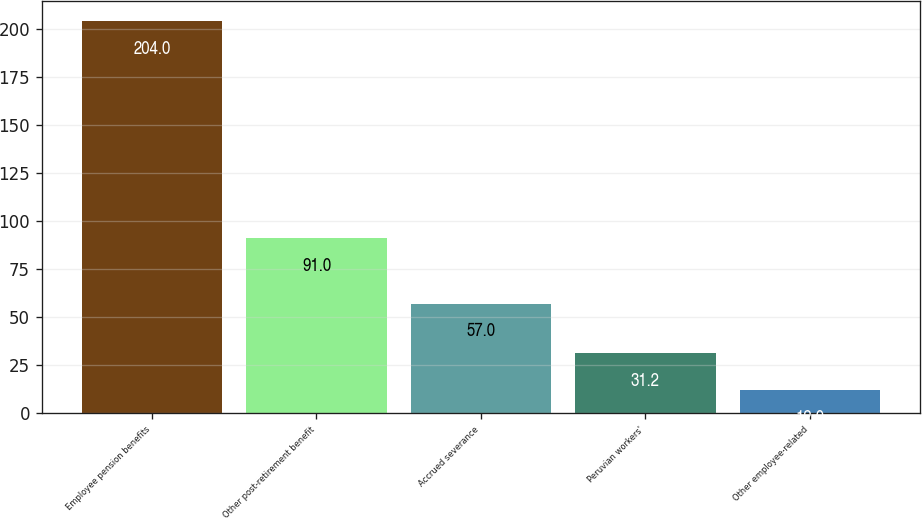Convert chart. <chart><loc_0><loc_0><loc_500><loc_500><bar_chart><fcel>Employee pension benefits<fcel>Other post-retirement benefit<fcel>Accrued severance<fcel>Peruvian workers'<fcel>Other employee-related<nl><fcel>204<fcel>91<fcel>57<fcel>31.2<fcel>12<nl></chart> 